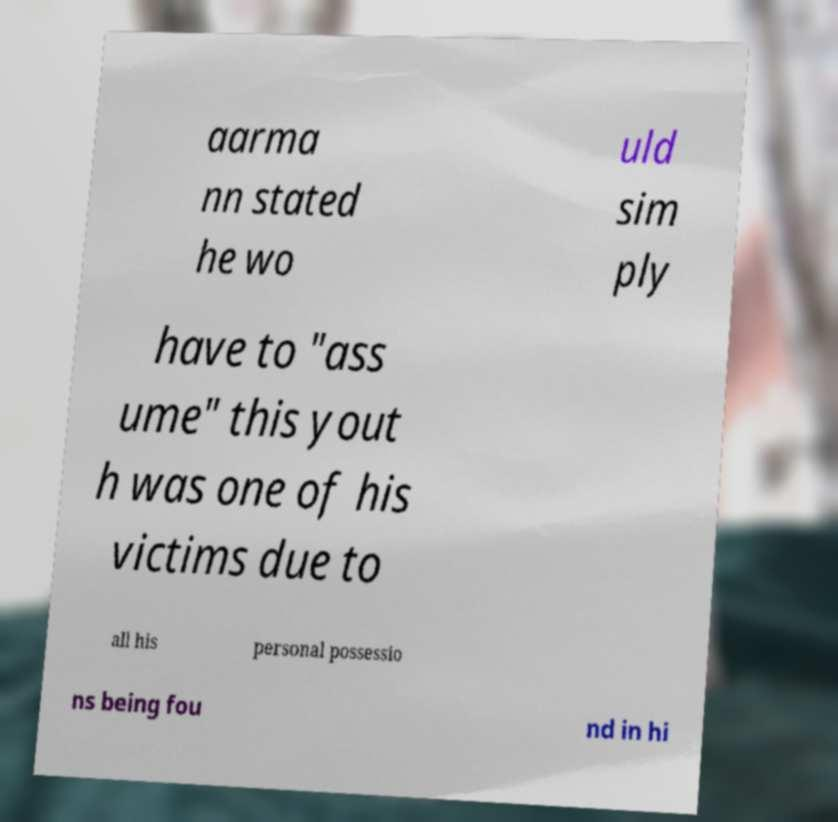Can you accurately transcribe the text from the provided image for me? aarma nn stated he wo uld sim ply have to "ass ume" this yout h was one of his victims due to all his personal possessio ns being fou nd in hi 